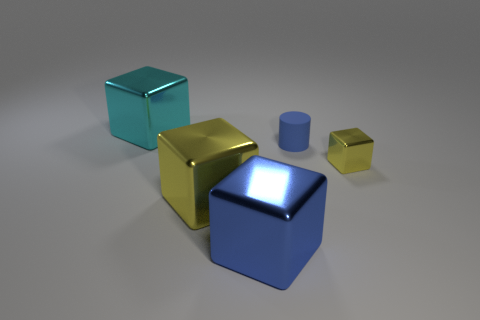How many other things are there of the same size as the blue matte object?
Give a very brief answer. 1. Do the large shiny thing behind the big yellow metallic object and the yellow metal object left of the small metallic block have the same shape?
Ensure brevity in your answer.  Yes. There is a small matte cylinder; are there any tiny blue cylinders in front of it?
Your answer should be compact. No. There is a small thing that is the same shape as the big yellow object; what color is it?
Your answer should be compact. Yellow. Are there any other things that are the same shape as the cyan metal object?
Ensure brevity in your answer.  Yes. There is a yellow thing that is to the left of the small blue cylinder; what is it made of?
Make the answer very short. Metal. The blue metal thing that is the same shape as the cyan shiny thing is what size?
Provide a succinct answer. Large. How many small yellow blocks have the same material as the large cyan block?
Your response must be concise. 1. How many big metallic cubes are the same color as the small shiny thing?
Give a very brief answer. 1. How many objects are big metal blocks left of the tiny blue matte cylinder or objects to the right of the cyan object?
Your answer should be very brief. 5. 